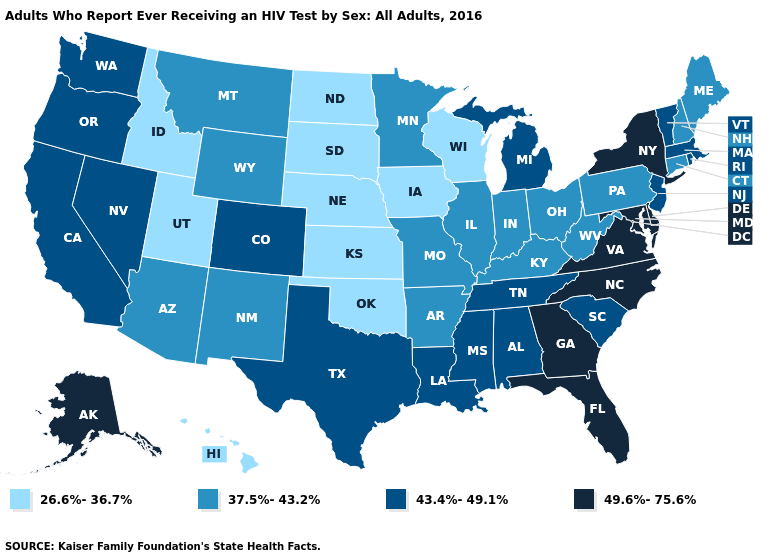Which states hav the highest value in the MidWest?
Concise answer only. Michigan. Name the states that have a value in the range 37.5%-43.2%?
Give a very brief answer. Arizona, Arkansas, Connecticut, Illinois, Indiana, Kentucky, Maine, Minnesota, Missouri, Montana, New Hampshire, New Mexico, Ohio, Pennsylvania, West Virginia, Wyoming. Does the first symbol in the legend represent the smallest category?
Short answer required. Yes. What is the value of Georgia?
Write a very short answer. 49.6%-75.6%. What is the highest value in the MidWest ?
Concise answer only. 43.4%-49.1%. What is the highest value in states that border Vermont?
Answer briefly. 49.6%-75.6%. What is the value of New Mexico?
Answer briefly. 37.5%-43.2%. What is the lowest value in the South?
Quick response, please. 26.6%-36.7%. What is the value of West Virginia?
Be succinct. 37.5%-43.2%. Which states have the lowest value in the USA?
Be succinct. Hawaii, Idaho, Iowa, Kansas, Nebraska, North Dakota, Oklahoma, South Dakota, Utah, Wisconsin. What is the highest value in the USA?
Short answer required. 49.6%-75.6%. What is the lowest value in states that border Massachusetts?
Concise answer only. 37.5%-43.2%. Which states have the lowest value in the MidWest?
Write a very short answer. Iowa, Kansas, Nebraska, North Dakota, South Dakota, Wisconsin. What is the value of Hawaii?
Answer briefly. 26.6%-36.7%. Is the legend a continuous bar?
Be succinct. No. 